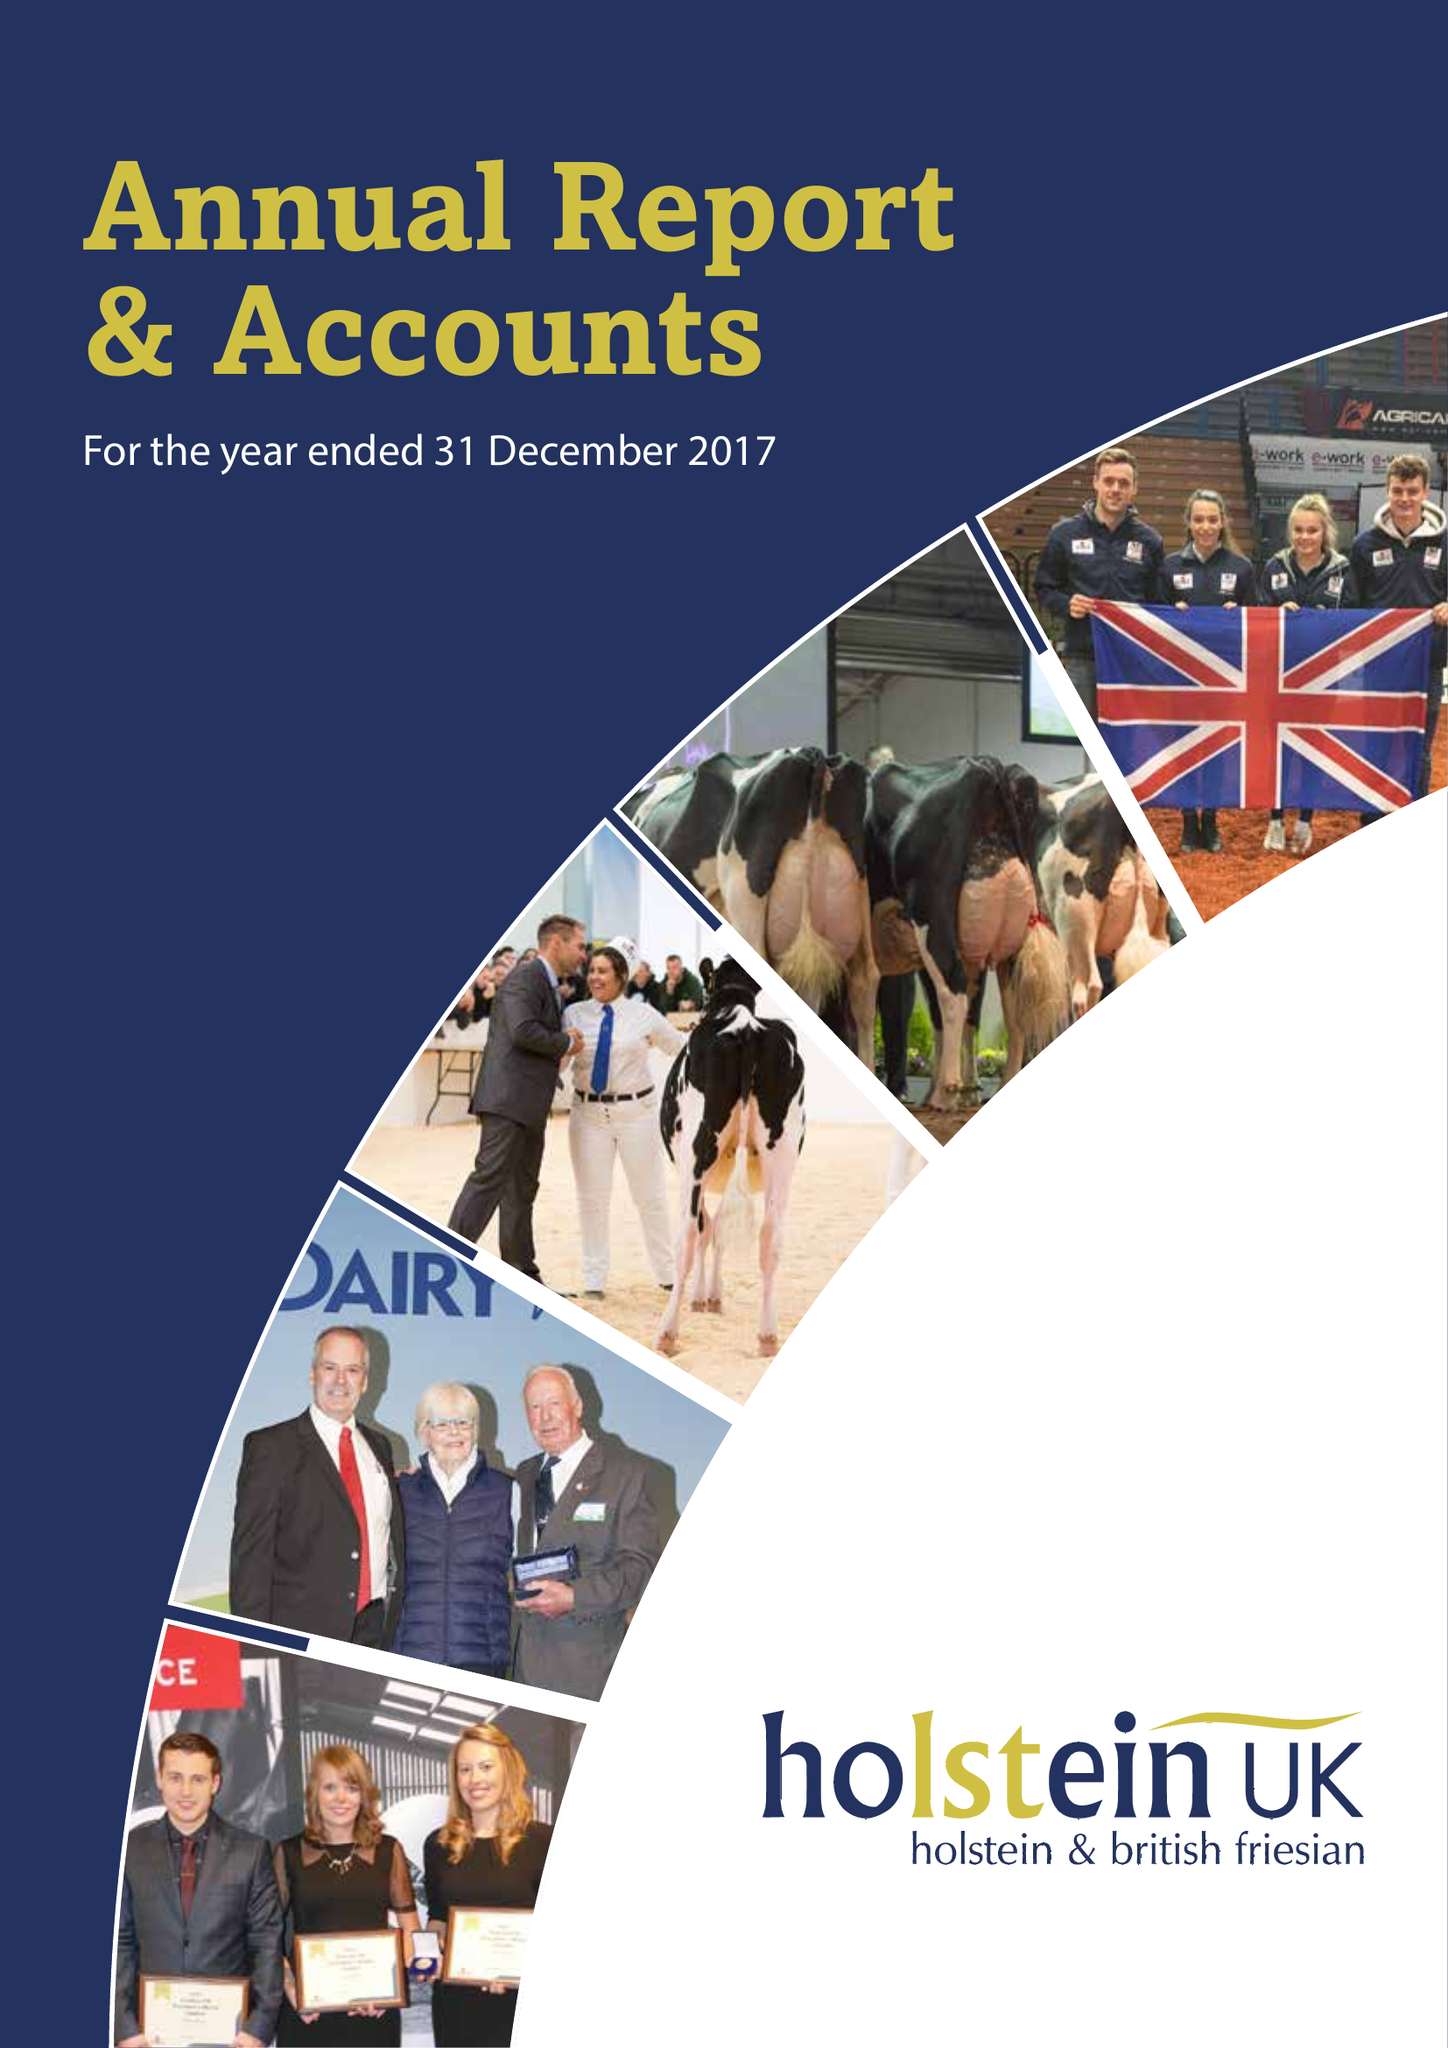What is the value for the address__postcode?
Answer the question using a single word or phrase. TF3 3BD 